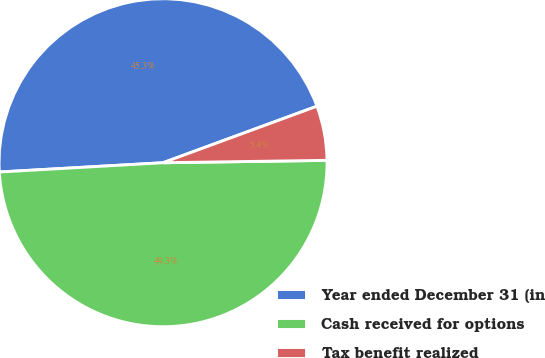<chart> <loc_0><loc_0><loc_500><loc_500><pie_chart><fcel>Year ended December 31 (in<fcel>Cash received for options<fcel>Tax benefit realized<nl><fcel>45.3%<fcel>49.33%<fcel>5.37%<nl></chart> 